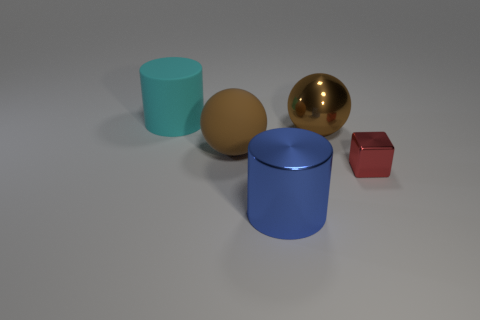What number of brown things are either big matte blocks or small metal objects?
Make the answer very short. 0. There is a shiny thing that is in front of the tiny red shiny object; is its color the same as the matte cylinder?
Your response must be concise. No. What is the size of the brown object that is in front of the brown ball to the right of the metallic cylinder?
Your answer should be very brief. Large. There is a blue thing that is the same size as the cyan matte cylinder; what material is it?
Your answer should be compact. Metal. What number of other objects are there of the same size as the cyan rubber thing?
Provide a succinct answer. 3. How many cylinders are either brown rubber objects or large cyan things?
Make the answer very short. 1. There is a cylinder behind the shiny object that is on the right side of the shiny object that is behind the red thing; what is it made of?
Your answer should be compact. Rubber. There is another ball that is the same color as the metallic ball; what is it made of?
Offer a very short reply. Rubber. What number of other small things have the same material as the blue thing?
Offer a terse response. 1. There is a rubber thing that is behind the metallic ball; is its size the same as the red block?
Offer a terse response. No. 